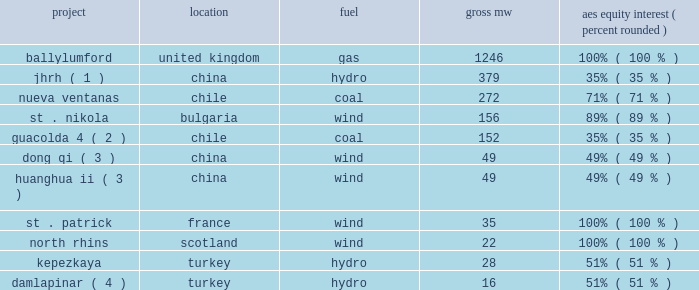2022 integration of new projects .
During 2010 , the following projects were acquired or commenced commercial operations : project location fuel aes equity interest ( percent , rounded ) .
Damlapinar ( 4 ) .
Turkey hydro 16 51% ( 51 % ) ( 1 ) jianghe rural electrification development co .
Ltd .
( 201cjhrh 201d ) and aes china hydropower investment co .
Ltd .
Entered into an agreement to acquire a 49% ( 49 % ) interest in this joint venture in june 2010 .
Acquisition of 35% ( 35 % ) ownership was completed in june 2010 and the transfer of the remaining 14% ( 14 % ) ownership , which is subject to approval by the chinese government , is expected to be completed in may 2011 .
( 2 ) guacolda is an equity method investment indirectly held by aes through gener .
The aes equity interest reflects the 29% ( 29 % ) noncontrolling interests in gener .
( 3 ) joint venture with guohua energy investment co .
Ltd .
( 4 ) joint venture with i.c .
Energy .
Key trends and uncertainties our operations continue to face many risks as discussed in item 1a . 2014risk factors of this form 10-k .
Some of these challenges are also described above in key drivers of results in 2010 .
We continue to monitor our operations and address challenges as they arise .
Development .
During the past year , the company has successfully acquired and completed construction of a number of projects , totaling approximately 2404 mw , including the acquisition of ballylumford in the united kingdom and completion of construction of a number of projects in europe , chile and china .
However , as discussed in item 1a . 2014risk factors 2014our business is subject to substantial development uncertainties of this form 10-k , our development projects are subject to uncertainties .
Certain delays have occurred at the 670 mw maritza coal-fired project in bulgaria , and the project has not yet begun commercial operations .
As noted in note 10 2014debt included in item 8 of this form 10-k , as a result of these delays the project debt is in default and the company is working with its lenders to resolve the default .
In addition , as noted in item 3 . 2014legal proceedings , the company is in litigation with the contractor regarding the cause of delays .
At this time , we believe that maritza will commence commercial operations for at least some of the project 2019s capacity by the second half of 2011 .
However , commencement of commercial operations could be delayed beyond this time frame .
There can be no assurance that maritza will achieve commercial operations , in whole or in part , by the second half of 2011 , resolve the default with the lenders or prevail in the litigation referenced above , which could result in the loss of some or all of our investment or require additional funding for the project .
Any of these events could have a material adverse effect on the company 2019s operating results or financial position .
Global economic conditions .
During the past few years , economic conditions in some countries where our subsidiaries conduct business have deteriorated .
Although the economic conditions in several of these countries have improved in recent months , our businesses could be impacted in the event these recent trends do not continue. .
What percentage of mw from acquired or commenced commercial operations in 2010 were due to nueva ventana? 
Computations: (272 / 2404)
Answer: 0.11314. 